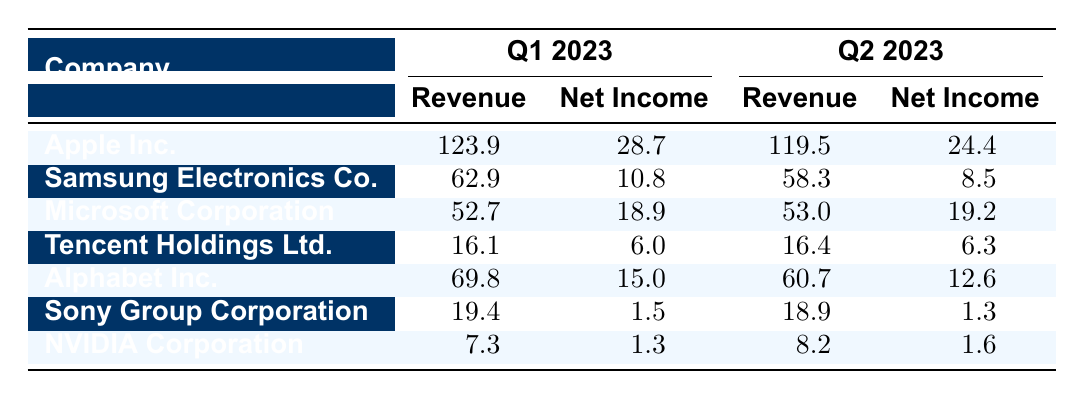What was the total revenue for Apple Inc. in Q1 2023? In Q1 2023, Apple Inc. reported a revenue of 123.9.
Answer: 123.9 What was the net income of Samsung Electronics Co. in Q2 2023? Samsung Electronics Co. reported a net income of 8.5 in Q2 2023.
Answer: 8.5 Which company had the highest revenue in Q1 2023? To find the highest revenue in Q1 2023, we compare revenues: Apple (123.9), Samsung (62.9), Microsoft (52.7), Tencent (16.1), Alphabet (69.8), Sony (19.4), and NVIDIA (7.3). Apple Inc. had the highest revenue at 123.9.
Answer: Apple Inc What is the difference in net income for Microsoft Corporation between Q1 2023 and Q2 2023? Microsoft's net income in Q1 2023 was 18.9, and in Q2 2023 it was 19.2. The difference is 19.2 - 18.9 = 0.3.
Answer: 0.3 What was the average EPS of the companies listed in Q1 2023? The EPS values for Q1 are 1.80 (Apple), 0.92 (Samsung), 2.45 (Microsoft), 0.21 (Tencent), 1.13 (Alphabet), 0.11 (Sony), and 0.52 (NVIDIA). The sum is 1.80 + 0.92 + 2.45 + 0.21 + 1.13 + 0.11 + 0.52 = 7.14, and there are 7 companies, so the average EPS is 7.14 / 7 = 1.02.
Answer: 1.02 Did Alphabet Inc. see an increase or decrease in revenue from Q1 2023 to Q2 2023? Alphabet Inc. had a revenue of 69.8 in Q1 2023 and 60.7 in Q2 2023. Since 60.7 is less than 69.8, there was a decrease in revenue.
Answer: Decrease Which company experienced the largest decrease in net income from Q1 2023 to Q2 2023? For each company, I compare net income: Apple (28.7 to 24.4, decrease of 4.3), Samsung (10.8 to 8.5, decrease of 2.3), Microsoft (18.9 to 19.2, increase), Tencent (6.0 to 6.3, increase), Alphabet (15.0 to 12.6, decrease of 2.4), Sony (1.5 to 1.3, decrease of 0.2), and NVIDIA (1.3 to 1.6, increase). The largest decrease is 4.3 for Apple Inc.
Answer: Apple Inc What was the total net income for all companies in Q2 2023? I sum the net incomes for Q2: Apple (24.4), Samsung (8.5), Microsoft (19.2), Tencent (6.3), Alphabet (12.6), Sony (1.3), and NVIDIA (1.6). The total is 24.4 + 8.5 + 19.2 + 6.3 + 12.6 + 1.3 + 1.6 = 73.0.
Answer: 73.0 Is the EPS of Samsung Electronics Co. higher in Q1 2023 compared to Q2 2023? Samsung's EPS in Q1 2023 is 0.92 and in Q2 2023 is 0.73. Since 0.92 is greater than 0.73, it is higher in Q1.
Answer: Yes Which region had the highest total revenue for the companies listed in Q1 2023? In Q1 2023, the Americas had Apple (123.9), Microsoft (52.7), and Alphabet (69.8) totaling 246.4. The Asia region had Samsung (62.9), Tencent (16.1), and Sony (19.4) totaling 98.4. The Americas had the highest revenue at 246.4.
Answer: Americas How much did the revenue of Tencent Holdings Ltd. change from Q1 2023 to Q2 2023? Tencent's revenue was 16.1 in Q1 2023 and 16.4 in Q2 2023. The change is 16.4 - 16.1 = 0.3.
Answer: 0.3 